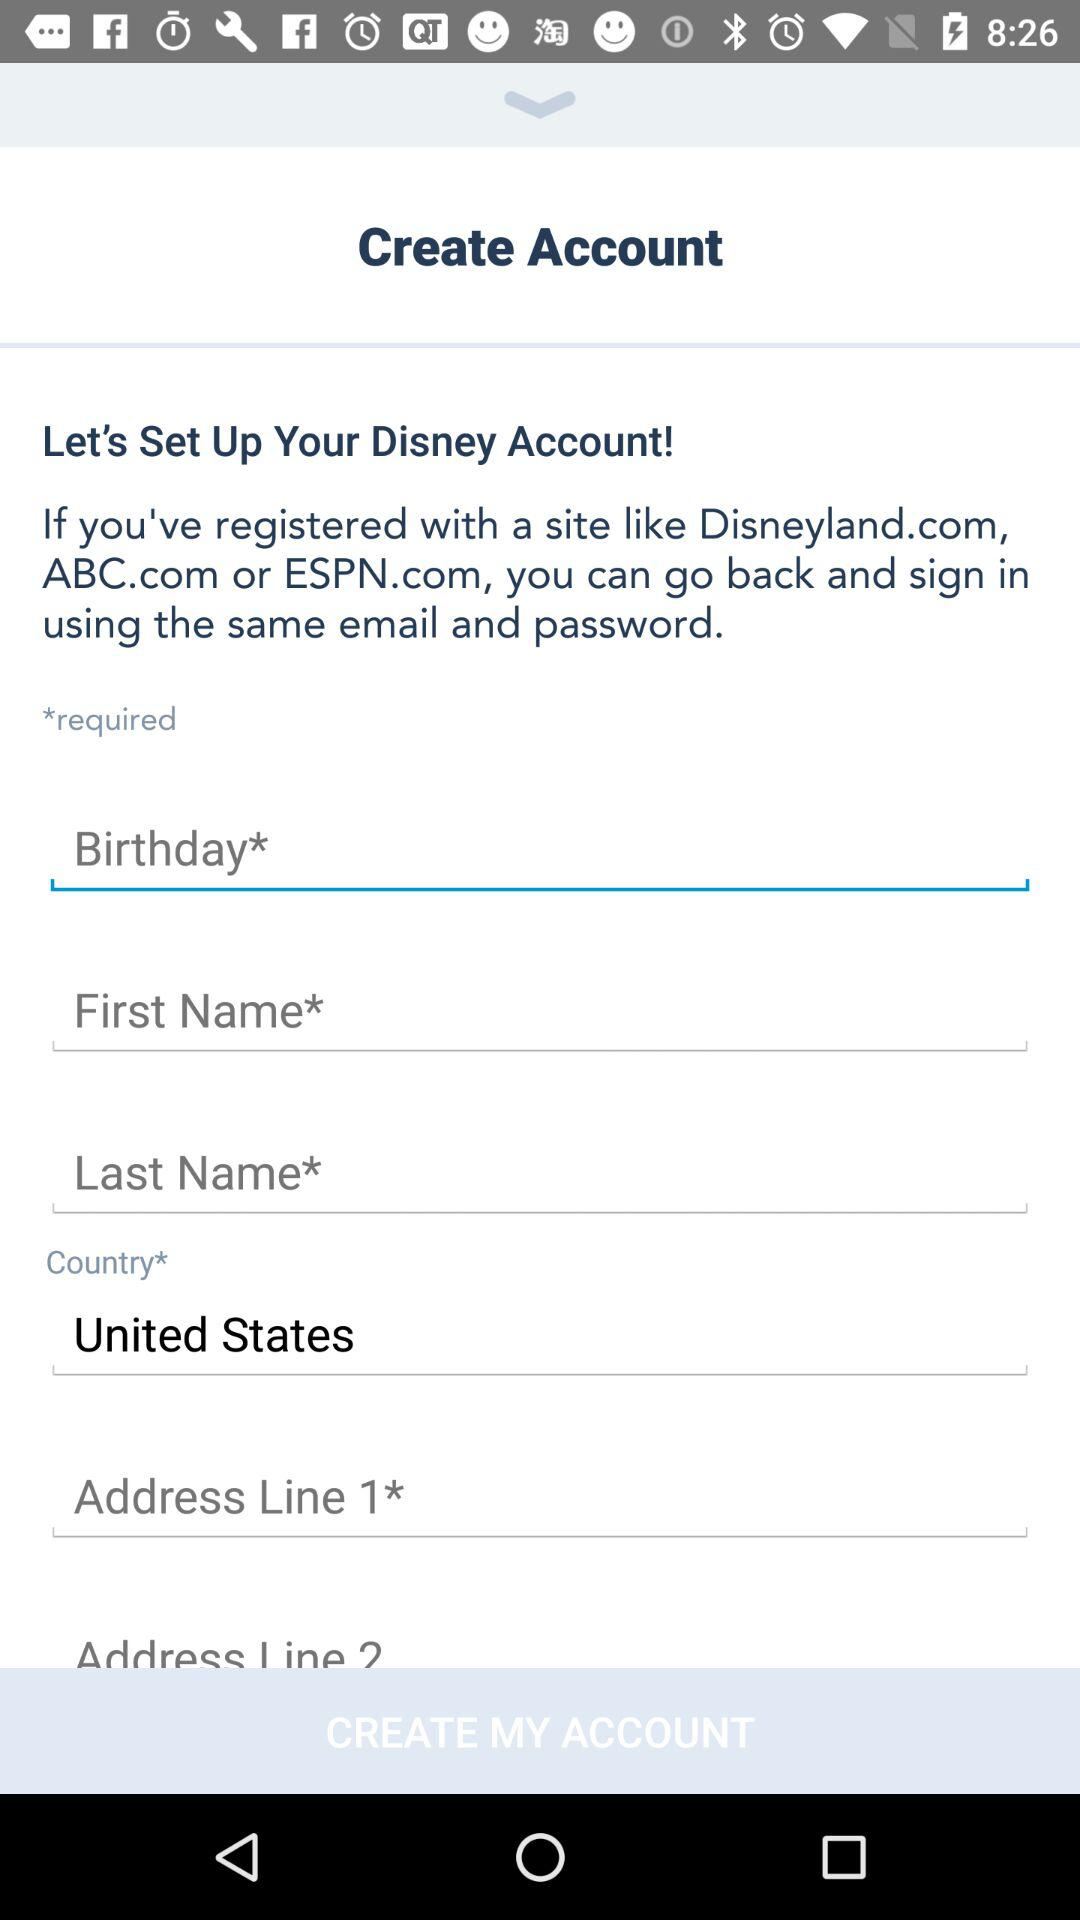What kind of authentication measures might be associated with creating an account on this platform? For account creation on such a platform, authentication measures may include creating a unique username and password, email or phone verification to confirm the user's identity, and security questions. Additionally, they may utilize CAPTCHA tests to ensure that the user is not a bot. 